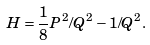Convert formula to latex. <formula><loc_0><loc_0><loc_500><loc_500>H = \frac { 1 } { 8 } P ^ { 2 } / Q ^ { 2 } - 1 / Q ^ { 2 } .</formula> 